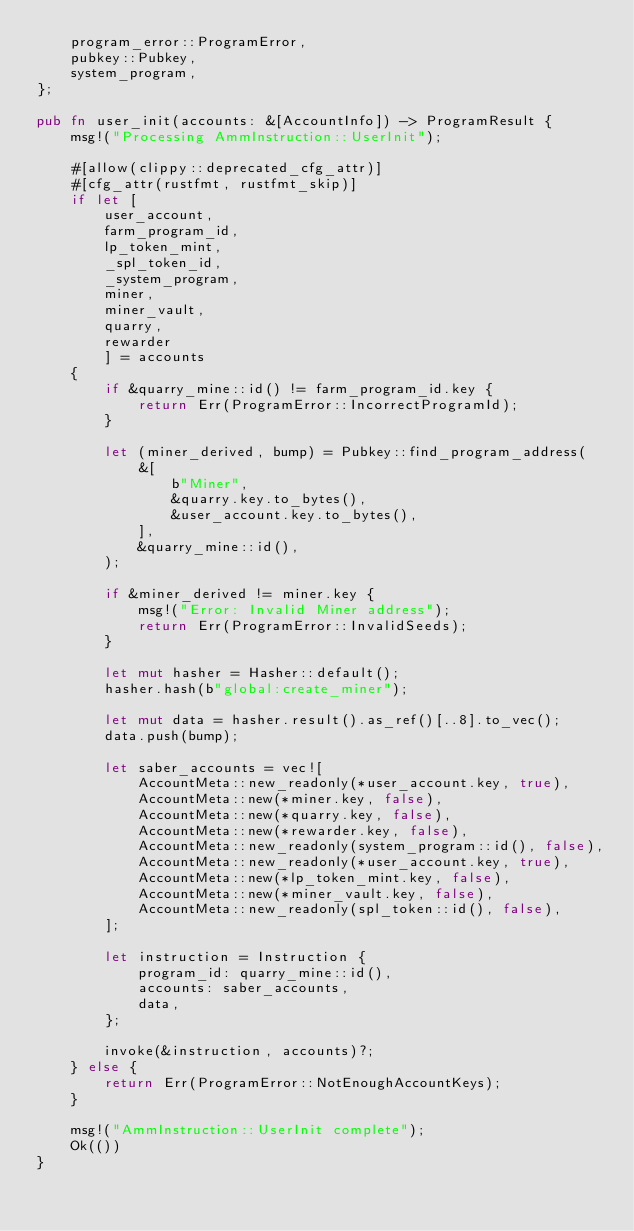<code> <loc_0><loc_0><loc_500><loc_500><_Rust_>    program_error::ProgramError,
    pubkey::Pubkey,
    system_program,
};

pub fn user_init(accounts: &[AccountInfo]) -> ProgramResult {
    msg!("Processing AmmInstruction::UserInit");

    #[allow(clippy::deprecated_cfg_attr)]
    #[cfg_attr(rustfmt, rustfmt_skip)]
    if let [
        user_account,
        farm_program_id,
        lp_token_mint,
        _spl_token_id,
        _system_program,
        miner,
        miner_vault,
        quarry,
        rewarder
        ] = accounts
    {
        if &quarry_mine::id() != farm_program_id.key {
            return Err(ProgramError::IncorrectProgramId);
        }

        let (miner_derived, bump) = Pubkey::find_program_address(
            &[
                b"Miner",
                &quarry.key.to_bytes(),
                &user_account.key.to_bytes(),
            ],
            &quarry_mine::id(),
        );

        if &miner_derived != miner.key {
            msg!("Error: Invalid Miner address");
            return Err(ProgramError::InvalidSeeds);
        }

        let mut hasher = Hasher::default();
        hasher.hash(b"global:create_miner");

        let mut data = hasher.result().as_ref()[..8].to_vec();
        data.push(bump);

        let saber_accounts = vec![
            AccountMeta::new_readonly(*user_account.key, true),
            AccountMeta::new(*miner.key, false),
            AccountMeta::new(*quarry.key, false),
            AccountMeta::new(*rewarder.key, false),
            AccountMeta::new_readonly(system_program::id(), false),
            AccountMeta::new_readonly(*user_account.key, true),
            AccountMeta::new(*lp_token_mint.key, false),
            AccountMeta::new(*miner_vault.key, false),
            AccountMeta::new_readonly(spl_token::id(), false),
        ];

        let instruction = Instruction {
            program_id: quarry_mine::id(),
            accounts: saber_accounts,
            data,
        };

        invoke(&instruction, accounts)?;
    } else {
        return Err(ProgramError::NotEnoughAccountKeys);
    }

    msg!("AmmInstruction::UserInit complete");
    Ok(())
}
</code> 